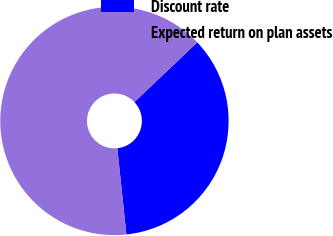<chart> <loc_0><loc_0><loc_500><loc_500><pie_chart><fcel>Discount rate<fcel>Expected return on plan assets<nl><fcel>35.41%<fcel>64.59%<nl></chart> 